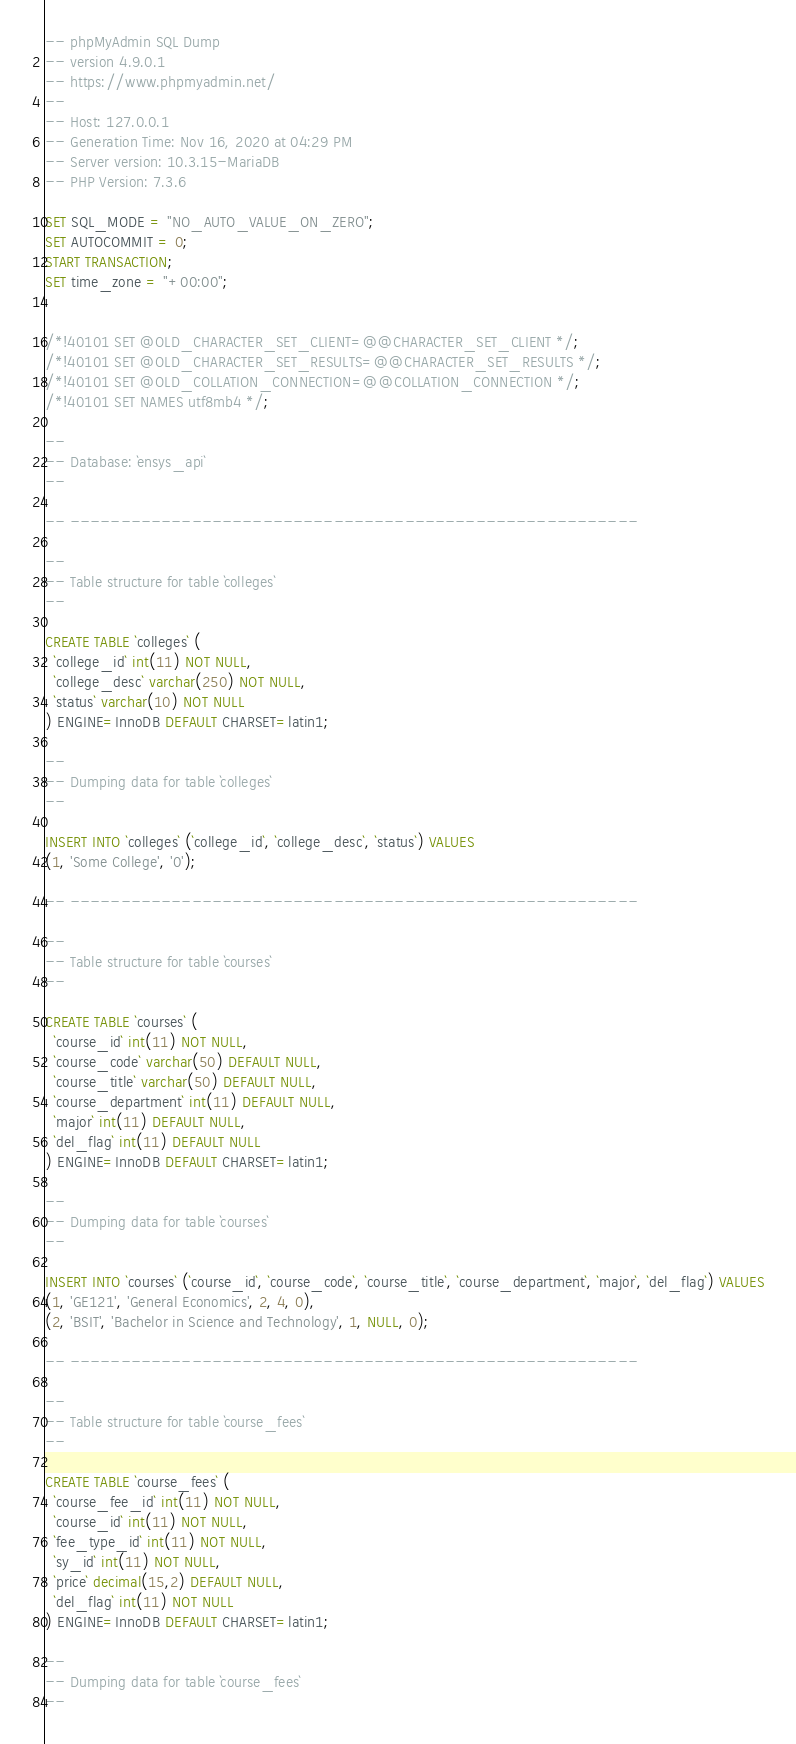Convert code to text. <code><loc_0><loc_0><loc_500><loc_500><_SQL_>-- phpMyAdmin SQL Dump
-- version 4.9.0.1
-- https://www.phpmyadmin.net/
--
-- Host: 127.0.0.1
-- Generation Time: Nov 16, 2020 at 04:29 PM
-- Server version: 10.3.15-MariaDB
-- PHP Version: 7.3.6

SET SQL_MODE = "NO_AUTO_VALUE_ON_ZERO";
SET AUTOCOMMIT = 0;
START TRANSACTION;
SET time_zone = "+00:00";


/*!40101 SET @OLD_CHARACTER_SET_CLIENT=@@CHARACTER_SET_CLIENT */;
/*!40101 SET @OLD_CHARACTER_SET_RESULTS=@@CHARACTER_SET_RESULTS */;
/*!40101 SET @OLD_COLLATION_CONNECTION=@@COLLATION_CONNECTION */;
/*!40101 SET NAMES utf8mb4 */;

--
-- Database: `ensys_api`
--

-- --------------------------------------------------------

--
-- Table structure for table `colleges`
--

CREATE TABLE `colleges` (
  `college_id` int(11) NOT NULL,
  `college_desc` varchar(250) NOT NULL,
  `status` varchar(10) NOT NULL
) ENGINE=InnoDB DEFAULT CHARSET=latin1;

--
-- Dumping data for table `colleges`
--

INSERT INTO `colleges` (`college_id`, `college_desc`, `status`) VALUES
(1, 'Some College', '0');

-- --------------------------------------------------------

--
-- Table structure for table `courses`
--

CREATE TABLE `courses` (
  `course_id` int(11) NOT NULL,
  `course_code` varchar(50) DEFAULT NULL,
  `course_title` varchar(50) DEFAULT NULL,
  `course_department` int(11) DEFAULT NULL,
  `major` int(11) DEFAULT NULL,
  `del_flag` int(11) DEFAULT NULL
) ENGINE=InnoDB DEFAULT CHARSET=latin1;

--
-- Dumping data for table `courses`
--

INSERT INTO `courses` (`course_id`, `course_code`, `course_title`, `course_department`, `major`, `del_flag`) VALUES
(1, 'GE121', 'General Economics', 2, 4, 0),
(2, 'BSIT', 'Bachelor in Science and Technology', 1, NULL, 0);

-- --------------------------------------------------------

--
-- Table structure for table `course_fees`
--

CREATE TABLE `course_fees` (
  `course_fee_id` int(11) NOT NULL,
  `course_id` int(11) NOT NULL,
  `fee_type_id` int(11) NOT NULL,
  `sy_id` int(11) NOT NULL,
  `price` decimal(15,2) DEFAULT NULL,
  `del_flag` int(11) NOT NULL
) ENGINE=InnoDB DEFAULT CHARSET=latin1;

--
-- Dumping data for table `course_fees`
--
</code> 